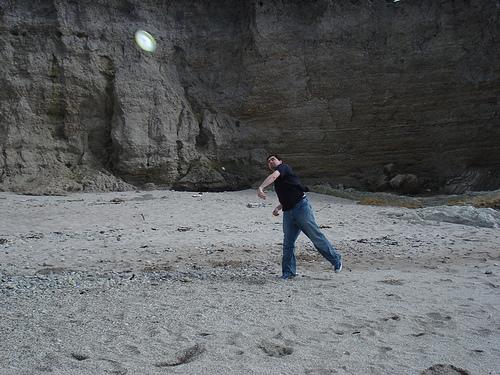Is the man doing aerobics?
Quick response, please. No. What is the person doing?
Short answer required. Throwing frisbee. What covers the ground?
Give a very brief answer. Sand. Is there a bird next to the rocks?
Answer briefly. No. What did the man throw?
Write a very short answer. Frisbee. How many people are shown?
Concise answer only. 1. Is the river dry?
Quick response, please. Yes. 